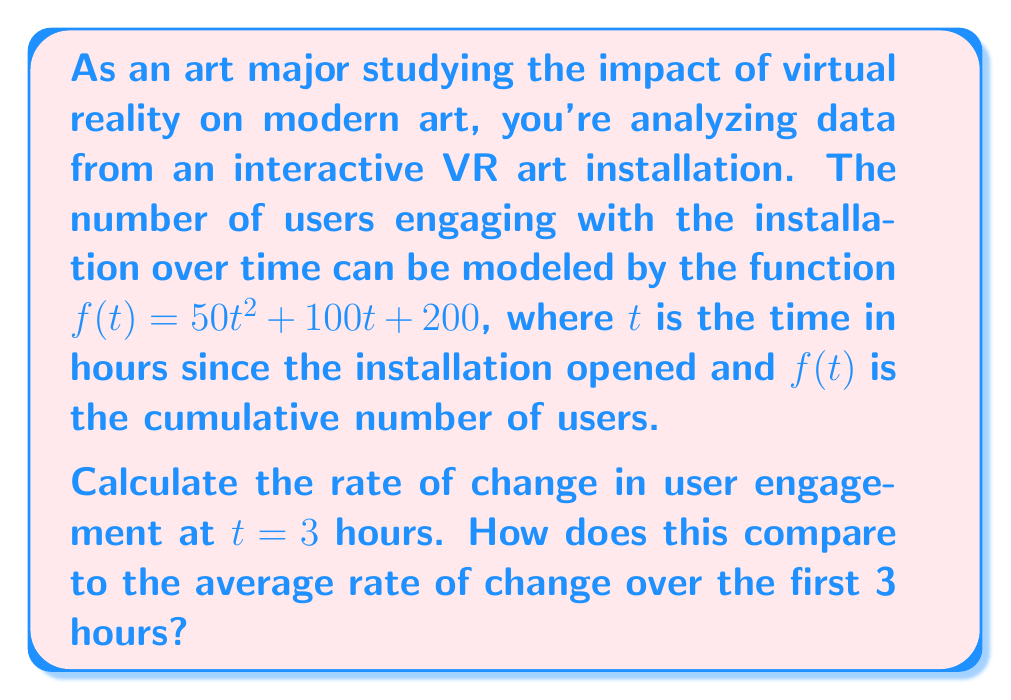Show me your answer to this math problem. To solve this problem, we need to find the instantaneous rate of change at $t = 3$ and compare it to the average rate of change over the interval $[0, 3]$.

1. Instantaneous rate of change at $t = 3$:
   The instantaneous rate of change is given by the derivative of $f(t)$ at $t = 3$.

   $$f'(t) = \frac{d}{dt}(50t^2 + 100t + 200) = 100t + 100$$

   At $t = 3$:
   $$f'(3) = 100(3) + 100 = 400$$

2. Average rate of change over $[0, 3]$:
   The average rate of change is calculated using the formula:
   $$\text{Average rate of change} = \frac{f(3) - f(0)}{3 - 0}$$

   Calculate $f(3)$ and $f(0)$:
   $$f(3) = 50(3)^2 + 100(3) + 200 = 450 + 300 + 200 = 950$$
   $$f(0) = 50(0)^2 + 100(0) + 200 = 200$$

   Now, calculate the average rate of change:
   $$\frac{f(3) - f(0)}{3 - 0} = \frac{950 - 200}{3} = \frac{750}{3} = 250$$

3. Comparison:
   The instantaneous rate of change at $t = 3$ is 400 users per hour.
   The average rate of change over the first 3 hours is 250 users per hour.

   The instantaneous rate at $t = 3$ is higher than the average rate, indicating that user engagement is accelerating.
Answer: The rate of change in user engagement at $t = 3$ hours is 400 users per hour. This is higher than the average rate of change over the first 3 hours, which is 250 users per hour, indicating accelerating user engagement. 